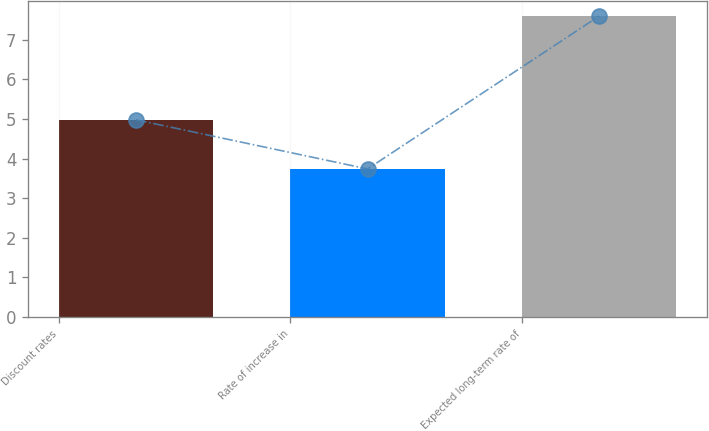Convert chart. <chart><loc_0><loc_0><loc_500><loc_500><bar_chart><fcel>Discount rates<fcel>Rate of increase in<fcel>Expected long-term rate of<nl><fcel>4.98<fcel>3.74<fcel>7.6<nl></chart> 